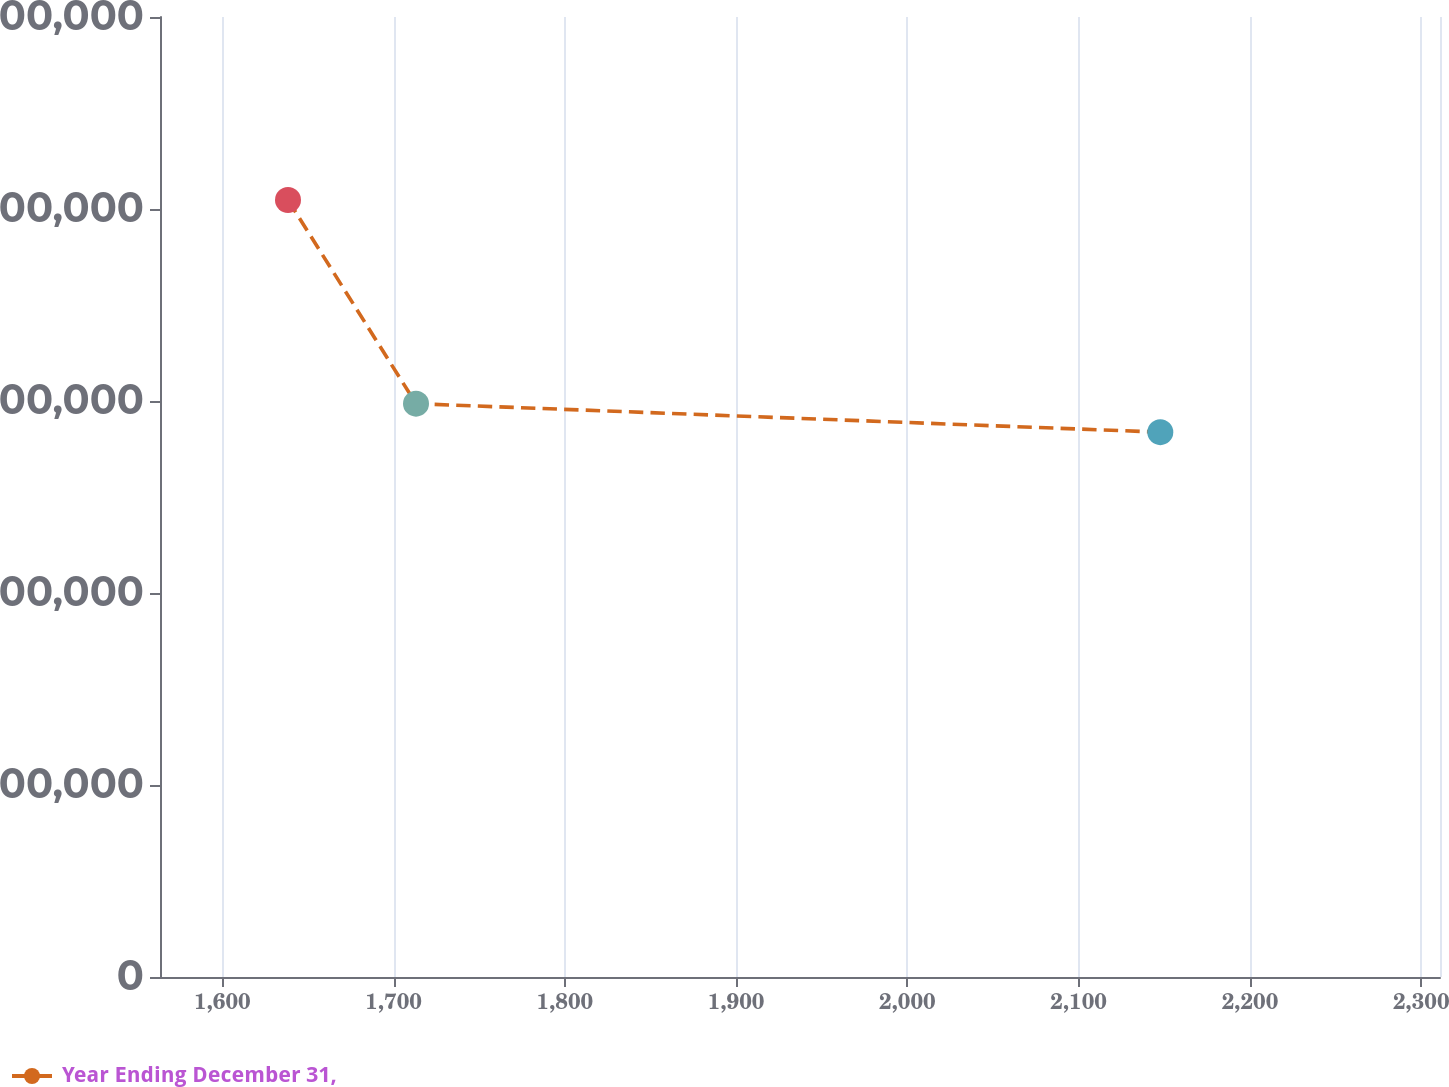Convert chart to OTSL. <chart><loc_0><loc_0><loc_500><loc_500><line_chart><ecel><fcel>Year Ending December 31,<nl><fcel>1638.34<fcel>8.09378e+06<nl><fcel>1713.08<fcel>5.97219e+06<nl><fcel>2147.65<fcel>5.67542e+06<nl><fcel>2385.7<fcel>6.44696e+06<nl></chart> 